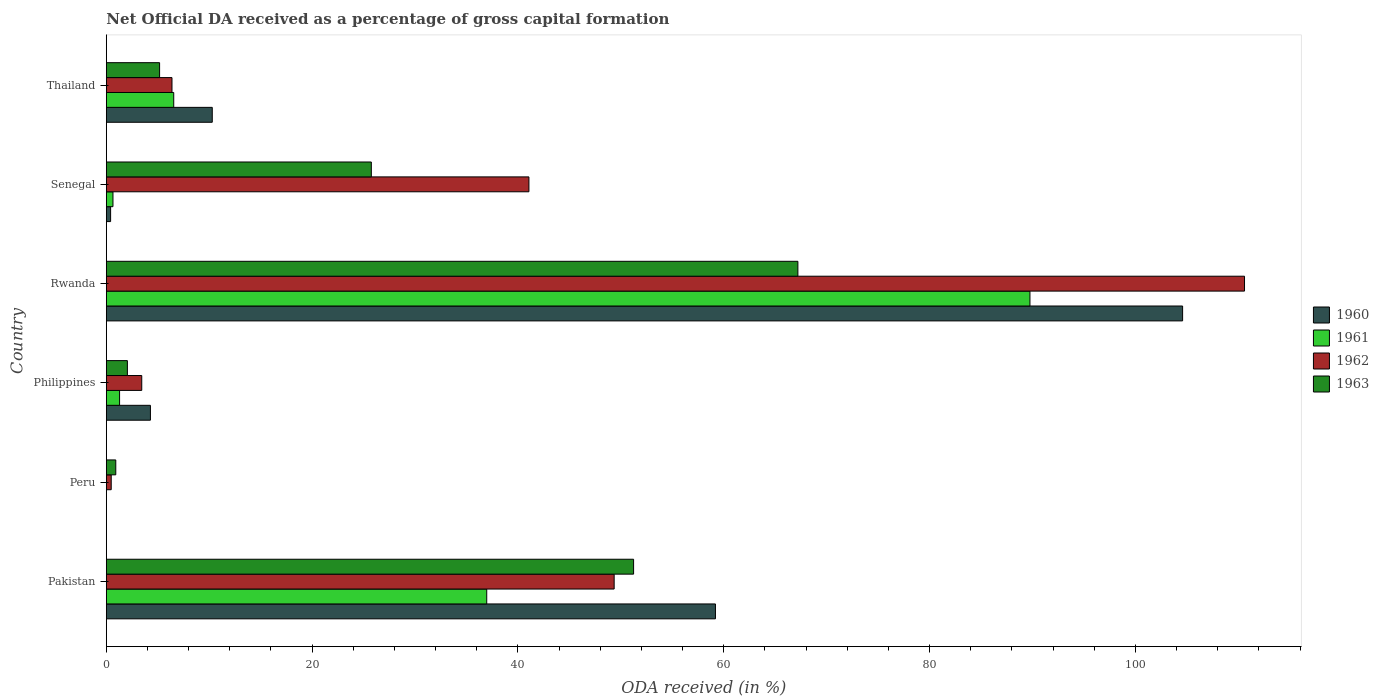Are the number of bars on each tick of the Y-axis equal?
Ensure brevity in your answer.  No. How many bars are there on the 3rd tick from the top?
Offer a terse response. 4. How many bars are there on the 1st tick from the bottom?
Keep it short and to the point. 4. What is the label of the 5th group of bars from the top?
Ensure brevity in your answer.  Peru. What is the net ODA received in 1961 in Senegal?
Ensure brevity in your answer.  0.65. Across all countries, what is the maximum net ODA received in 1961?
Ensure brevity in your answer.  89.75. Across all countries, what is the minimum net ODA received in 1962?
Provide a succinct answer. 0.47. In which country was the net ODA received in 1961 maximum?
Provide a succinct answer. Rwanda. What is the total net ODA received in 1962 in the graph?
Your response must be concise. 211.31. What is the difference between the net ODA received in 1962 in Pakistan and that in Philippines?
Provide a short and direct response. 45.91. What is the difference between the net ODA received in 1963 in Senegal and the net ODA received in 1962 in Philippines?
Offer a very short reply. 22.31. What is the average net ODA received in 1962 per country?
Provide a short and direct response. 35.22. What is the difference between the net ODA received in 1963 and net ODA received in 1960 in Senegal?
Your response must be concise. 25.33. What is the ratio of the net ODA received in 1962 in Philippines to that in Thailand?
Your response must be concise. 0.54. What is the difference between the highest and the second highest net ODA received in 1960?
Keep it short and to the point. 45.39. What is the difference between the highest and the lowest net ODA received in 1962?
Offer a very short reply. 110.13. In how many countries, is the net ODA received in 1960 greater than the average net ODA received in 1960 taken over all countries?
Provide a succinct answer. 2. Is the sum of the net ODA received in 1962 in Peru and Rwanda greater than the maximum net ODA received in 1963 across all countries?
Offer a terse response. Yes. Is it the case that in every country, the sum of the net ODA received in 1961 and net ODA received in 1960 is greater than the sum of net ODA received in 1963 and net ODA received in 1962?
Offer a terse response. No. Is it the case that in every country, the sum of the net ODA received in 1963 and net ODA received in 1960 is greater than the net ODA received in 1961?
Your answer should be compact. Yes. How many bars are there?
Make the answer very short. 22. What is the difference between two consecutive major ticks on the X-axis?
Provide a succinct answer. 20. Does the graph contain grids?
Your answer should be very brief. No. Where does the legend appear in the graph?
Your answer should be very brief. Center right. How are the legend labels stacked?
Give a very brief answer. Vertical. What is the title of the graph?
Offer a terse response. Net Official DA received as a percentage of gross capital formation. Does "1992" appear as one of the legend labels in the graph?
Your answer should be very brief. No. What is the label or title of the X-axis?
Offer a terse response. ODA received (in %). What is the ODA received (in %) of 1960 in Pakistan?
Provide a succinct answer. 59.19. What is the ODA received (in %) in 1961 in Pakistan?
Ensure brevity in your answer.  36.96. What is the ODA received (in %) in 1962 in Pakistan?
Your response must be concise. 49.35. What is the ODA received (in %) of 1963 in Pakistan?
Your response must be concise. 51.24. What is the ODA received (in %) in 1960 in Peru?
Keep it short and to the point. 0. What is the ODA received (in %) in 1962 in Peru?
Offer a very short reply. 0.47. What is the ODA received (in %) in 1963 in Peru?
Your response must be concise. 0.92. What is the ODA received (in %) in 1960 in Philippines?
Your answer should be very brief. 4.28. What is the ODA received (in %) in 1961 in Philippines?
Your answer should be compact. 1.29. What is the ODA received (in %) of 1962 in Philippines?
Provide a short and direct response. 3.44. What is the ODA received (in %) of 1963 in Philippines?
Ensure brevity in your answer.  2.05. What is the ODA received (in %) of 1960 in Rwanda?
Make the answer very short. 104.58. What is the ODA received (in %) of 1961 in Rwanda?
Offer a very short reply. 89.75. What is the ODA received (in %) of 1962 in Rwanda?
Your response must be concise. 110.6. What is the ODA received (in %) in 1963 in Rwanda?
Your response must be concise. 67.2. What is the ODA received (in %) in 1960 in Senegal?
Make the answer very short. 0.42. What is the ODA received (in %) in 1961 in Senegal?
Offer a very short reply. 0.65. What is the ODA received (in %) in 1962 in Senegal?
Provide a succinct answer. 41.06. What is the ODA received (in %) in 1963 in Senegal?
Your answer should be compact. 25.75. What is the ODA received (in %) in 1960 in Thailand?
Your answer should be very brief. 10.29. What is the ODA received (in %) in 1961 in Thailand?
Keep it short and to the point. 6.55. What is the ODA received (in %) of 1962 in Thailand?
Offer a very short reply. 6.38. What is the ODA received (in %) of 1963 in Thailand?
Offer a very short reply. 5.18. Across all countries, what is the maximum ODA received (in %) of 1960?
Ensure brevity in your answer.  104.58. Across all countries, what is the maximum ODA received (in %) of 1961?
Give a very brief answer. 89.75. Across all countries, what is the maximum ODA received (in %) in 1962?
Provide a short and direct response. 110.6. Across all countries, what is the maximum ODA received (in %) in 1963?
Ensure brevity in your answer.  67.2. Across all countries, what is the minimum ODA received (in %) in 1962?
Keep it short and to the point. 0.47. Across all countries, what is the minimum ODA received (in %) of 1963?
Provide a short and direct response. 0.92. What is the total ODA received (in %) of 1960 in the graph?
Your answer should be very brief. 178.77. What is the total ODA received (in %) in 1961 in the graph?
Offer a terse response. 135.2. What is the total ODA received (in %) in 1962 in the graph?
Keep it short and to the point. 211.31. What is the total ODA received (in %) of 1963 in the graph?
Give a very brief answer. 152.33. What is the difference between the ODA received (in %) in 1962 in Pakistan and that in Peru?
Give a very brief answer. 48.87. What is the difference between the ODA received (in %) in 1963 in Pakistan and that in Peru?
Offer a very short reply. 50.32. What is the difference between the ODA received (in %) of 1960 in Pakistan and that in Philippines?
Your answer should be compact. 54.9. What is the difference between the ODA received (in %) in 1961 in Pakistan and that in Philippines?
Offer a terse response. 35.68. What is the difference between the ODA received (in %) of 1962 in Pakistan and that in Philippines?
Give a very brief answer. 45.91. What is the difference between the ODA received (in %) in 1963 in Pakistan and that in Philippines?
Keep it short and to the point. 49.19. What is the difference between the ODA received (in %) in 1960 in Pakistan and that in Rwanda?
Your answer should be very brief. -45.39. What is the difference between the ODA received (in %) in 1961 in Pakistan and that in Rwanda?
Provide a succinct answer. -52.79. What is the difference between the ODA received (in %) of 1962 in Pakistan and that in Rwanda?
Your response must be concise. -61.25. What is the difference between the ODA received (in %) of 1963 in Pakistan and that in Rwanda?
Your answer should be very brief. -15.96. What is the difference between the ODA received (in %) in 1960 in Pakistan and that in Senegal?
Your response must be concise. 58.77. What is the difference between the ODA received (in %) in 1961 in Pakistan and that in Senegal?
Make the answer very short. 36.32. What is the difference between the ODA received (in %) of 1962 in Pakistan and that in Senegal?
Your answer should be very brief. 8.28. What is the difference between the ODA received (in %) of 1963 in Pakistan and that in Senegal?
Give a very brief answer. 25.48. What is the difference between the ODA received (in %) of 1960 in Pakistan and that in Thailand?
Ensure brevity in your answer.  48.9. What is the difference between the ODA received (in %) in 1961 in Pakistan and that in Thailand?
Provide a succinct answer. 30.41. What is the difference between the ODA received (in %) in 1962 in Pakistan and that in Thailand?
Make the answer very short. 42.97. What is the difference between the ODA received (in %) of 1963 in Pakistan and that in Thailand?
Ensure brevity in your answer.  46.06. What is the difference between the ODA received (in %) of 1962 in Peru and that in Philippines?
Give a very brief answer. -2.97. What is the difference between the ODA received (in %) of 1963 in Peru and that in Philippines?
Make the answer very short. -1.13. What is the difference between the ODA received (in %) in 1962 in Peru and that in Rwanda?
Keep it short and to the point. -110.13. What is the difference between the ODA received (in %) in 1963 in Peru and that in Rwanda?
Provide a succinct answer. -66.28. What is the difference between the ODA received (in %) in 1962 in Peru and that in Senegal?
Provide a short and direct response. -40.59. What is the difference between the ODA received (in %) of 1963 in Peru and that in Senegal?
Give a very brief answer. -24.83. What is the difference between the ODA received (in %) in 1962 in Peru and that in Thailand?
Keep it short and to the point. -5.91. What is the difference between the ODA received (in %) in 1963 in Peru and that in Thailand?
Your answer should be compact. -4.26. What is the difference between the ODA received (in %) in 1960 in Philippines and that in Rwanda?
Offer a terse response. -100.3. What is the difference between the ODA received (in %) of 1961 in Philippines and that in Rwanda?
Offer a terse response. -88.46. What is the difference between the ODA received (in %) of 1962 in Philippines and that in Rwanda?
Provide a succinct answer. -107.16. What is the difference between the ODA received (in %) of 1963 in Philippines and that in Rwanda?
Your response must be concise. -65.15. What is the difference between the ODA received (in %) of 1960 in Philippines and that in Senegal?
Provide a short and direct response. 3.87. What is the difference between the ODA received (in %) of 1961 in Philippines and that in Senegal?
Make the answer very short. 0.64. What is the difference between the ODA received (in %) of 1962 in Philippines and that in Senegal?
Make the answer very short. -37.62. What is the difference between the ODA received (in %) in 1963 in Philippines and that in Senegal?
Offer a very short reply. -23.7. What is the difference between the ODA received (in %) in 1960 in Philippines and that in Thailand?
Your answer should be compact. -6.01. What is the difference between the ODA received (in %) in 1961 in Philippines and that in Thailand?
Your response must be concise. -5.26. What is the difference between the ODA received (in %) of 1962 in Philippines and that in Thailand?
Ensure brevity in your answer.  -2.94. What is the difference between the ODA received (in %) of 1963 in Philippines and that in Thailand?
Your answer should be very brief. -3.13. What is the difference between the ODA received (in %) of 1960 in Rwanda and that in Senegal?
Your answer should be compact. 104.17. What is the difference between the ODA received (in %) in 1961 in Rwanda and that in Senegal?
Provide a succinct answer. 89.1. What is the difference between the ODA received (in %) in 1962 in Rwanda and that in Senegal?
Your answer should be compact. 69.54. What is the difference between the ODA received (in %) in 1963 in Rwanda and that in Senegal?
Give a very brief answer. 41.45. What is the difference between the ODA received (in %) in 1960 in Rwanda and that in Thailand?
Provide a short and direct response. 94.29. What is the difference between the ODA received (in %) of 1961 in Rwanda and that in Thailand?
Offer a terse response. 83.2. What is the difference between the ODA received (in %) of 1962 in Rwanda and that in Thailand?
Your answer should be very brief. 104.22. What is the difference between the ODA received (in %) in 1963 in Rwanda and that in Thailand?
Your answer should be compact. 62.02. What is the difference between the ODA received (in %) of 1960 in Senegal and that in Thailand?
Your answer should be very brief. -9.88. What is the difference between the ODA received (in %) in 1961 in Senegal and that in Thailand?
Keep it short and to the point. -5.91. What is the difference between the ODA received (in %) of 1962 in Senegal and that in Thailand?
Keep it short and to the point. 34.68. What is the difference between the ODA received (in %) of 1963 in Senegal and that in Thailand?
Make the answer very short. 20.57. What is the difference between the ODA received (in %) in 1960 in Pakistan and the ODA received (in %) in 1962 in Peru?
Your answer should be very brief. 58.71. What is the difference between the ODA received (in %) of 1960 in Pakistan and the ODA received (in %) of 1963 in Peru?
Your response must be concise. 58.27. What is the difference between the ODA received (in %) of 1961 in Pakistan and the ODA received (in %) of 1962 in Peru?
Provide a succinct answer. 36.49. What is the difference between the ODA received (in %) in 1961 in Pakistan and the ODA received (in %) in 1963 in Peru?
Your answer should be very brief. 36.05. What is the difference between the ODA received (in %) in 1962 in Pakistan and the ODA received (in %) in 1963 in Peru?
Provide a short and direct response. 48.43. What is the difference between the ODA received (in %) in 1960 in Pakistan and the ODA received (in %) in 1961 in Philippines?
Your response must be concise. 57.9. What is the difference between the ODA received (in %) in 1960 in Pakistan and the ODA received (in %) in 1962 in Philippines?
Offer a terse response. 55.75. What is the difference between the ODA received (in %) of 1960 in Pakistan and the ODA received (in %) of 1963 in Philippines?
Your answer should be compact. 57.14. What is the difference between the ODA received (in %) in 1961 in Pakistan and the ODA received (in %) in 1962 in Philippines?
Make the answer very short. 33.52. What is the difference between the ODA received (in %) of 1961 in Pakistan and the ODA received (in %) of 1963 in Philippines?
Your answer should be compact. 34.92. What is the difference between the ODA received (in %) in 1962 in Pakistan and the ODA received (in %) in 1963 in Philippines?
Make the answer very short. 47.3. What is the difference between the ODA received (in %) of 1960 in Pakistan and the ODA received (in %) of 1961 in Rwanda?
Offer a terse response. -30.56. What is the difference between the ODA received (in %) of 1960 in Pakistan and the ODA received (in %) of 1962 in Rwanda?
Make the answer very short. -51.41. What is the difference between the ODA received (in %) of 1960 in Pakistan and the ODA received (in %) of 1963 in Rwanda?
Offer a very short reply. -8.01. What is the difference between the ODA received (in %) in 1961 in Pakistan and the ODA received (in %) in 1962 in Rwanda?
Your answer should be compact. -73.64. What is the difference between the ODA received (in %) in 1961 in Pakistan and the ODA received (in %) in 1963 in Rwanda?
Keep it short and to the point. -30.24. What is the difference between the ODA received (in %) of 1962 in Pakistan and the ODA received (in %) of 1963 in Rwanda?
Keep it short and to the point. -17.85. What is the difference between the ODA received (in %) of 1960 in Pakistan and the ODA received (in %) of 1961 in Senegal?
Your answer should be very brief. 58.54. What is the difference between the ODA received (in %) in 1960 in Pakistan and the ODA received (in %) in 1962 in Senegal?
Give a very brief answer. 18.12. What is the difference between the ODA received (in %) in 1960 in Pakistan and the ODA received (in %) in 1963 in Senegal?
Your response must be concise. 33.44. What is the difference between the ODA received (in %) of 1961 in Pakistan and the ODA received (in %) of 1962 in Senegal?
Give a very brief answer. -4.1. What is the difference between the ODA received (in %) in 1961 in Pakistan and the ODA received (in %) in 1963 in Senegal?
Offer a very short reply. 11.21. What is the difference between the ODA received (in %) of 1962 in Pakistan and the ODA received (in %) of 1963 in Senegal?
Your answer should be very brief. 23.6. What is the difference between the ODA received (in %) of 1960 in Pakistan and the ODA received (in %) of 1961 in Thailand?
Keep it short and to the point. 52.64. What is the difference between the ODA received (in %) of 1960 in Pakistan and the ODA received (in %) of 1962 in Thailand?
Provide a succinct answer. 52.81. What is the difference between the ODA received (in %) in 1960 in Pakistan and the ODA received (in %) in 1963 in Thailand?
Give a very brief answer. 54.01. What is the difference between the ODA received (in %) of 1961 in Pakistan and the ODA received (in %) of 1962 in Thailand?
Your answer should be very brief. 30.58. What is the difference between the ODA received (in %) of 1961 in Pakistan and the ODA received (in %) of 1963 in Thailand?
Provide a short and direct response. 31.79. What is the difference between the ODA received (in %) of 1962 in Pakistan and the ODA received (in %) of 1963 in Thailand?
Give a very brief answer. 44.17. What is the difference between the ODA received (in %) in 1962 in Peru and the ODA received (in %) in 1963 in Philippines?
Your response must be concise. -1.57. What is the difference between the ODA received (in %) in 1962 in Peru and the ODA received (in %) in 1963 in Rwanda?
Provide a succinct answer. -66.73. What is the difference between the ODA received (in %) in 1962 in Peru and the ODA received (in %) in 1963 in Senegal?
Provide a short and direct response. -25.28. What is the difference between the ODA received (in %) in 1962 in Peru and the ODA received (in %) in 1963 in Thailand?
Offer a terse response. -4.7. What is the difference between the ODA received (in %) of 1960 in Philippines and the ODA received (in %) of 1961 in Rwanda?
Keep it short and to the point. -85.47. What is the difference between the ODA received (in %) of 1960 in Philippines and the ODA received (in %) of 1962 in Rwanda?
Make the answer very short. -106.32. What is the difference between the ODA received (in %) in 1960 in Philippines and the ODA received (in %) in 1963 in Rwanda?
Make the answer very short. -62.92. What is the difference between the ODA received (in %) of 1961 in Philippines and the ODA received (in %) of 1962 in Rwanda?
Offer a terse response. -109.31. What is the difference between the ODA received (in %) in 1961 in Philippines and the ODA received (in %) in 1963 in Rwanda?
Offer a very short reply. -65.91. What is the difference between the ODA received (in %) in 1962 in Philippines and the ODA received (in %) in 1963 in Rwanda?
Ensure brevity in your answer.  -63.76. What is the difference between the ODA received (in %) of 1960 in Philippines and the ODA received (in %) of 1961 in Senegal?
Your answer should be very brief. 3.64. What is the difference between the ODA received (in %) of 1960 in Philippines and the ODA received (in %) of 1962 in Senegal?
Your answer should be very brief. -36.78. What is the difference between the ODA received (in %) of 1960 in Philippines and the ODA received (in %) of 1963 in Senegal?
Make the answer very short. -21.47. What is the difference between the ODA received (in %) of 1961 in Philippines and the ODA received (in %) of 1962 in Senegal?
Provide a short and direct response. -39.78. What is the difference between the ODA received (in %) in 1961 in Philippines and the ODA received (in %) in 1963 in Senegal?
Your answer should be compact. -24.46. What is the difference between the ODA received (in %) in 1962 in Philippines and the ODA received (in %) in 1963 in Senegal?
Your answer should be very brief. -22.31. What is the difference between the ODA received (in %) of 1960 in Philippines and the ODA received (in %) of 1961 in Thailand?
Provide a short and direct response. -2.27. What is the difference between the ODA received (in %) of 1960 in Philippines and the ODA received (in %) of 1962 in Thailand?
Your response must be concise. -2.1. What is the difference between the ODA received (in %) in 1960 in Philippines and the ODA received (in %) in 1963 in Thailand?
Provide a succinct answer. -0.89. What is the difference between the ODA received (in %) in 1961 in Philippines and the ODA received (in %) in 1962 in Thailand?
Give a very brief answer. -5.09. What is the difference between the ODA received (in %) in 1961 in Philippines and the ODA received (in %) in 1963 in Thailand?
Your response must be concise. -3.89. What is the difference between the ODA received (in %) of 1962 in Philippines and the ODA received (in %) of 1963 in Thailand?
Make the answer very short. -1.73. What is the difference between the ODA received (in %) in 1960 in Rwanda and the ODA received (in %) in 1961 in Senegal?
Keep it short and to the point. 103.94. What is the difference between the ODA received (in %) of 1960 in Rwanda and the ODA received (in %) of 1962 in Senegal?
Ensure brevity in your answer.  63.52. What is the difference between the ODA received (in %) in 1960 in Rwanda and the ODA received (in %) in 1963 in Senegal?
Offer a very short reply. 78.83. What is the difference between the ODA received (in %) in 1961 in Rwanda and the ODA received (in %) in 1962 in Senegal?
Make the answer very short. 48.69. What is the difference between the ODA received (in %) of 1961 in Rwanda and the ODA received (in %) of 1963 in Senegal?
Make the answer very short. 64. What is the difference between the ODA received (in %) in 1962 in Rwanda and the ODA received (in %) in 1963 in Senegal?
Your response must be concise. 84.85. What is the difference between the ODA received (in %) in 1960 in Rwanda and the ODA received (in %) in 1961 in Thailand?
Offer a very short reply. 98.03. What is the difference between the ODA received (in %) in 1960 in Rwanda and the ODA received (in %) in 1962 in Thailand?
Your response must be concise. 98.2. What is the difference between the ODA received (in %) of 1960 in Rwanda and the ODA received (in %) of 1963 in Thailand?
Your response must be concise. 99.41. What is the difference between the ODA received (in %) of 1961 in Rwanda and the ODA received (in %) of 1962 in Thailand?
Keep it short and to the point. 83.37. What is the difference between the ODA received (in %) in 1961 in Rwanda and the ODA received (in %) in 1963 in Thailand?
Offer a terse response. 84.57. What is the difference between the ODA received (in %) of 1962 in Rwanda and the ODA received (in %) of 1963 in Thailand?
Keep it short and to the point. 105.42. What is the difference between the ODA received (in %) in 1960 in Senegal and the ODA received (in %) in 1961 in Thailand?
Offer a very short reply. -6.13. What is the difference between the ODA received (in %) of 1960 in Senegal and the ODA received (in %) of 1962 in Thailand?
Provide a succinct answer. -5.96. What is the difference between the ODA received (in %) in 1960 in Senegal and the ODA received (in %) in 1963 in Thailand?
Provide a short and direct response. -4.76. What is the difference between the ODA received (in %) of 1961 in Senegal and the ODA received (in %) of 1962 in Thailand?
Your answer should be very brief. -5.73. What is the difference between the ODA received (in %) of 1961 in Senegal and the ODA received (in %) of 1963 in Thailand?
Your answer should be very brief. -4.53. What is the difference between the ODA received (in %) in 1962 in Senegal and the ODA received (in %) in 1963 in Thailand?
Make the answer very short. 35.89. What is the average ODA received (in %) of 1960 per country?
Offer a very short reply. 29.79. What is the average ODA received (in %) in 1961 per country?
Provide a succinct answer. 22.53. What is the average ODA received (in %) of 1962 per country?
Provide a succinct answer. 35.22. What is the average ODA received (in %) in 1963 per country?
Offer a very short reply. 25.39. What is the difference between the ODA received (in %) of 1960 and ODA received (in %) of 1961 in Pakistan?
Offer a terse response. 22.22. What is the difference between the ODA received (in %) in 1960 and ODA received (in %) in 1962 in Pakistan?
Provide a short and direct response. 9.84. What is the difference between the ODA received (in %) in 1960 and ODA received (in %) in 1963 in Pakistan?
Make the answer very short. 7.95. What is the difference between the ODA received (in %) in 1961 and ODA received (in %) in 1962 in Pakistan?
Ensure brevity in your answer.  -12.38. What is the difference between the ODA received (in %) of 1961 and ODA received (in %) of 1963 in Pakistan?
Ensure brevity in your answer.  -14.27. What is the difference between the ODA received (in %) in 1962 and ODA received (in %) in 1963 in Pakistan?
Keep it short and to the point. -1.89. What is the difference between the ODA received (in %) of 1962 and ODA received (in %) of 1963 in Peru?
Your answer should be compact. -0.44. What is the difference between the ODA received (in %) in 1960 and ODA received (in %) in 1961 in Philippines?
Provide a succinct answer. 3. What is the difference between the ODA received (in %) in 1960 and ODA received (in %) in 1962 in Philippines?
Keep it short and to the point. 0.84. What is the difference between the ODA received (in %) in 1960 and ODA received (in %) in 1963 in Philippines?
Your response must be concise. 2.24. What is the difference between the ODA received (in %) of 1961 and ODA received (in %) of 1962 in Philippines?
Make the answer very short. -2.15. What is the difference between the ODA received (in %) in 1961 and ODA received (in %) in 1963 in Philippines?
Offer a terse response. -0.76. What is the difference between the ODA received (in %) in 1962 and ODA received (in %) in 1963 in Philippines?
Make the answer very short. 1.4. What is the difference between the ODA received (in %) in 1960 and ODA received (in %) in 1961 in Rwanda?
Provide a short and direct response. 14.83. What is the difference between the ODA received (in %) in 1960 and ODA received (in %) in 1962 in Rwanda?
Your answer should be compact. -6.02. What is the difference between the ODA received (in %) of 1960 and ODA received (in %) of 1963 in Rwanda?
Offer a very short reply. 37.38. What is the difference between the ODA received (in %) of 1961 and ODA received (in %) of 1962 in Rwanda?
Ensure brevity in your answer.  -20.85. What is the difference between the ODA received (in %) in 1961 and ODA received (in %) in 1963 in Rwanda?
Make the answer very short. 22.55. What is the difference between the ODA received (in %) in 1962 and ODA received (in %) in 1963 in Rwanda?
Your answer should be very brief. 43.4. What is the difference between the ODA received (in %) of 1960 and ODA received (in %) of 1961 in Senegal?
Provide a short and direct response. -0.23. What is the difference between the ODA received (in %) in 1960 and ODA received (in %) in 1962 in Senegal?
Offer a very short reply. -40.65. What is the difference between the ODA received (in %) in 1960 and ODA received (in %) in 1963 in Senegal?
Provide a short and direct response. -25.33. What is the difference between the ODA received (in %) in 1961 and ODA received (in %) in 1962 in Senegal?
Give a very brief answer. -40.42. What is the difference between the ODA received (in %) of 1961 and ODA received (in %) of 1963 in Senegal?
Offer a very short reply. -25.11. What is the difference between the ODA received (in %) in 1962 and ODA received (in %) in 1963 in Senegal?
Provide a short and direct response. 15.31. What is the difference between the ODA received (in %) in 1960 and ODA received (in %) in 1961 in Thailand?
Your answer should be compact. 3.74. What is the difference between the ODA received (in %) in 1960 and ODA received (in %) in 1962 in Thailand?
Provide a short and direct response. 3.91. What is the difference between the ODA received (in %) in 1960 and ODA received (in %) in 1963 in Thailand?
Make the answer very short. 5.12. What is the difference between the ODA received (in %) in 1961 and ODA received (in %) in 1962 in Thailand?
Provide a short and direct response. 0.17. What is the difference between the ODA received (in %) of 1961 and ODA received (in %) of 1963 in Thailand?
Provide a short and direct response. 1.37. What is the difference between the ODA received (in %) in 1962 and ODA received (in %) in 1963 in Thailand?
Offer a terse response. 1.2. What is the ratio of the ODA received (in %) of 1962 in Pakistan to that in Peru?
Offer a very short reply. 104.06. What is the ratio of the ODA received (in %) in 1963 in Pakistan to that in Peru?
Your answer should be very brief. 55.85. What is the ratio of the ODA received (in %) in 1960 in Pakistan to that in Philippines?
Provide a short and direct response. 13.82. What is the ratio of the ODA received (in %) of 1961 in Pakistan to that in Philippines?
Offer a very short reply. 28.71. What is the ratio of the ODA received (in %) of 1962 in Pakistan to that in Philippines?
Provide a short and direct response. 14.34. What is the ratio of the ODA received (in %) of 1963 in Pakistan to that in Philippines?
Provide a short and direct response. 25.04. What is the ratio of the ODA received (in %) in 1960 in Pakistan to that in Rwanda?
Keep it short and to the point. 0.57. What is the ratio of the ODA received (in %) in 1961 in Pakistan to that in Rwanda?
Offer a terse response. 0.41. What is the ratio of the ODA received (in %) in 1962 in Pakistan to that in Rwanda?
Keep it short and to the point. 0.45. What is the ratio of the ODA received (in %) of 1963 in Pakistan to that in Rwanda?
Your answer should be compact. 0.76. What is the ratio of the ODA received (in %) in 1960 in Pakistan to that in Senegal?
Keep it short and to the point. 142.26. What is the ratio of the ODA received (in %) of 1961 in Pakistan to that in Senegal?
Your response must be concise. 57.3. What is the ratio of the ODA received (in %) of 1962 in Pakistan to that in Senegal?
Your answer should be very brief. 1.2. What is the ratio of the ODA received (in %) in 1963 in Pakistan to that in Senegal?
Provide a short and direct response. 1.99. What is the ratio of the ODA received (in %) of 1960 in Pakistan to that in Thailand?
Keep it short and to the point. 5.75. What is the ratio of the ODA received (in %) in 1961 in Pakistan to that in Thailand?
Offer a very short reply. 5.64. What is the ratio of the ODA received (in %) of 1962 in Pakistan to that in Thailand?
Offer a terse response. 7.73. What is the ratio of the ODA received (in %) of 1963 in Pakistan to that in Thailand?
Your answer should be very brief. 9.9. What is the ratio of the ODA received (in %) of 1962 in Peru to that in Philippines?
Your answer should be compact. 0.14. What is the ratio of the ODA received (in %) in 1963 in Peru to that in Philippines?
Offer a terse response. 0.45. What is the ratio of the ODA received (in %) of 1962 in Peru to that in Rwanda?
Your answer should be compact. 0. What is the ratio of the ODA received (in %) in 1963 in Peru to that in Rwanda?
Give a very brief answer. 0.01. What is the ratio of the ODA received (in %) of 1962 in Peru to that in Senegal?
Give a very brief answer. 0.01. What is the ratio of the ODA received (in %) in 1963 in Peru to that in Senegal?
Ensure brevity in your answer.  0.04. What is the ratio of the ODA received (in %) of 1962 in Peru to that in Thailand?
Make the answer very short. 0.07. What is the ratio of the ODA received (in %) of 1963 in Peru to that in Thailand?
Your response must be concise. 0.18. What is the ratio of the ODA received (in %) of 1960 in Philippines to that in Rwanda?
Your answer should be very brief. 0.04. What is the ratio of the ODA received (in %) of 1961 in Philippines to that in Rwanda?
Your response must be concise. 0.01. What is the ratio of the ODA received (in %) in 1962 in Philippines to that in Rwanda?
Ensure brevity in your answer.  0.03. What is the ratio of the ODA received (in %) of 1963 in Philippines to that in Rwanda?
Give a very brief answer. 0.03. What is the ratio of the ODA received (in %) in 1960 in Philippines to that in Senegal?
Ensure brevity in your answer.  10.3. What is the ratio of the ODA received (in %) in 1961 in Philippines to that in Senegal?
Give a very brief answer. 2. What is the ratio of the ODA received (in %) of 1962 in Philippines to that in Senegal?
Offer a terse response. 0.08. What is the ratio of the ODA received (in %) of 1963 in Philippines to that in Senegal?
Keep it short and to the point. 0.08. What is the ratio of the ODA received (in %) of 1960 in Philippines to that in Thailand?
Give a very brief answer. 0.42. What is the ratio of the ODA received (in %) in 1961 in Philippines to that in Thailand?
Your response must be concise. 0.2. What is the ratio of the ODA received (in %) in 1962 in Philippines to that in Thailand?
Offer a very short reply. 0.54. What is the ratio of the ODA received (in %) of 1963 in Philippines to that in Thailand?
Provide a short and direct response. 0.4. What is the ratio of the ODA received (in %) in 1960 in Rwanda to that in Senegal?
Provide a short and direct response. 251.36. What is the ratio of the ODA received (in %) of 1961 in Rwanda to that in Senegal?
Make the answer very short. 139.13. What is the ratio of the ODA received (in %) in 1962 in Rwanda to that in Senegal?
Your answer should be very brief. 2.69. What is the ratio of the ODA received (in %) in 1963 in Rwanda to that in Senegal?
Make the answer very short. 2.61. What is the ratio of the ODA received (in %) of 1960 in Rwanda to that in Thailand?
Keep it short and to the point. 10.16. What is the ratio of the ODA received (in %) in 1961 in Rwanda to that in Thailand?
Provide a succinct answer. 13.7. What is the ratio of the ODA received (in %) in 1962 in Rwanda to that in Thailand?
Your answer should be very brief. 17.34. What is the ratio of the ODA received (in %) in 1963 in Rwanda to that in Thailand?
Your answer should be compact. 12.98. What is the ratio of the ODA received (in %) in 1960 in Senegal to that in Thailand?
Provide a short and direct response. 0.04. What is the ratio of the ODA received (in %) of 1961 in Senegal to that in Thailand?
Your answer should be compact. 0.1. What is the ratio of the ODA received (in %) of 1962 in Senegal to that in Thailand?
Your answer should be very brief. 6.44. What is the ratio of the ODA received (in %) of 1963 in Senegal to that in Thailand?
Your answer should be very brief. 4.97. What is the difference between the highest and the second highest ODA received (in %) in 1960?
Offer a very short reply. 45.39. What is the difference between the highest and the second highest ODA received (in %) in 1961?
Your response must be concise. 52.79. What is the difference between the highest and the second highest ODA received (in %) in 1962?
Give a very brief answer. 61.25. What is the difference between the highest and the second highest ODA received (in %) in 1963?
Keep it short and to the point. 15.96. What is the difference between the highest and the lowest ODA received (in %) in 1960?
Your response must be concise. 104.58. What is the difference between the highest and the lowest ODA received (in %) in 1961?
Make the answer very short. 89.75. What is the difference between the highest and the lowest ODA received (in %) in 1962?
Provide a short and direct response. 110.13. What is the difference between the highest and the lowest ODA received (in %) of 1963?
Your response must be concise. 66.28. 